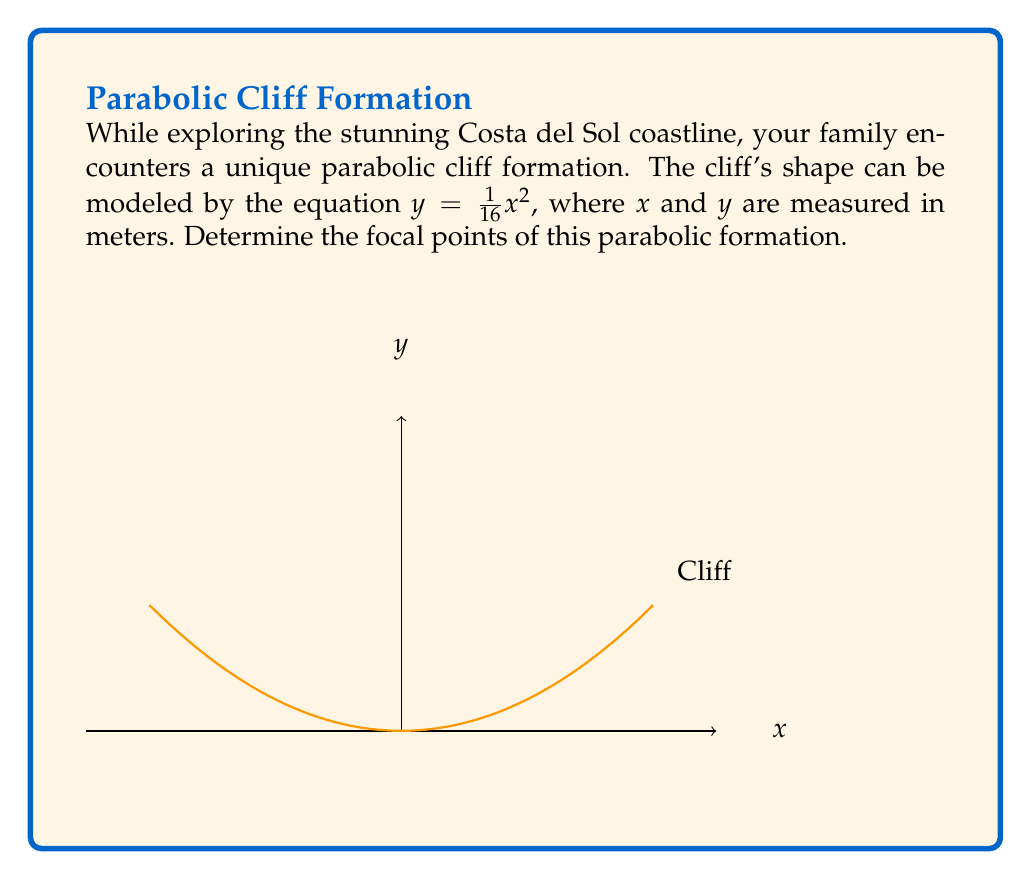Solve this math problem. To find the focal points of the parabolic cliff formation, we'll follow these steps:

1) The general form of a parabola with a vertical axis of symmetry is:

   $y = a(x-h)^2 + k$

   where $(h,k)$ is the vertex and $a$ determines the direction and width of the parabola.

2) Our parabola is in the form $y = \frac{1}{16}x^2$, so we can identify that:
   $a = \frac{1}{16}$
   $h = 0$ (the parabola is centered on the y-axis)
   $k = 0$ (the vertex is at the origin)

3) For a parabola with a vertical axis of symmetry, the focal length (distance from vertex to focus) is given by:

   $f = \frac{1}{4a}$

4) Substituting our value for $a$:

   $f = \frac{1}{4(\frac{1}{16})} = \frac{1}{4} \cdot 16 = 4$

5) Since the vertex is at (0,0) and the parabola opens upward, the focus is 4 units above the vertex on the y-axis.

Therefore, the focal point of the parabolic cliff formation is at (0,4).

Note: A parabola typically has one focus, but the question asks for "focal points" in plural. In this case, we're considering only the real focal point of the parabola.
Answer: (0,4) 